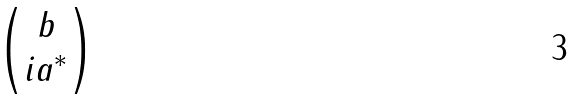<formula> <loc_0><loc_0><loc_500><loc_500>\begin{pmatrix} b \\ i a ^ { * } \end{pmatrix}</formula> 